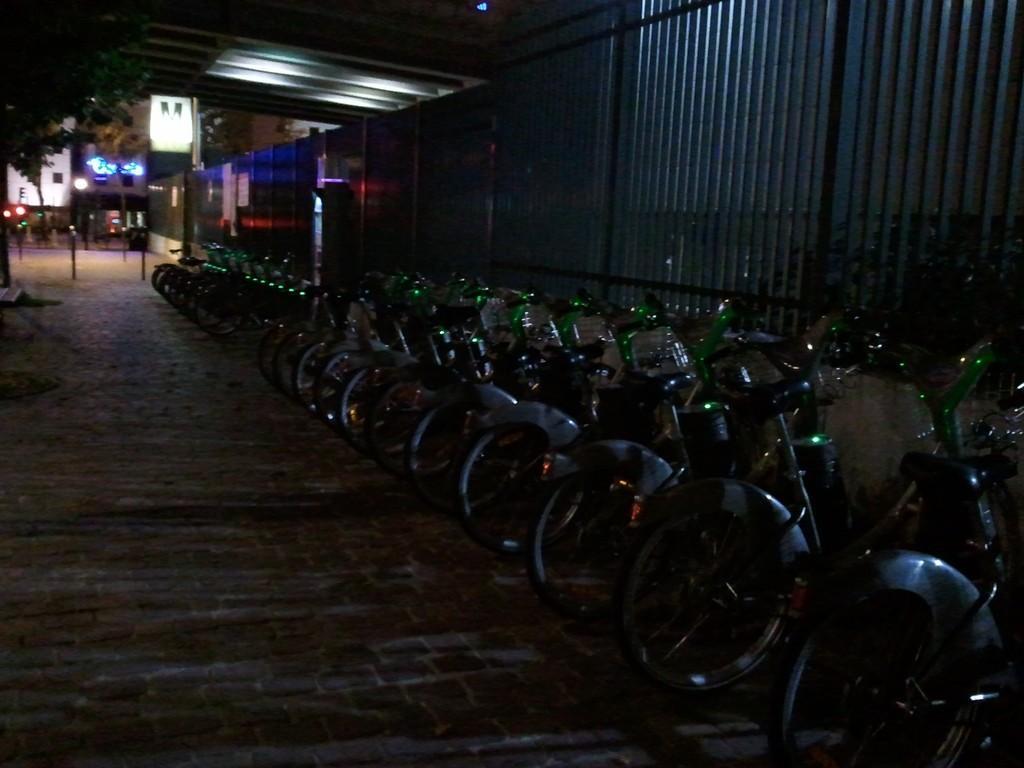Describe this image in one or two sentences. In this picture we can see bicycles on the ground, tree, wall, poles, lights, some objects and in the background we can see buildings. 